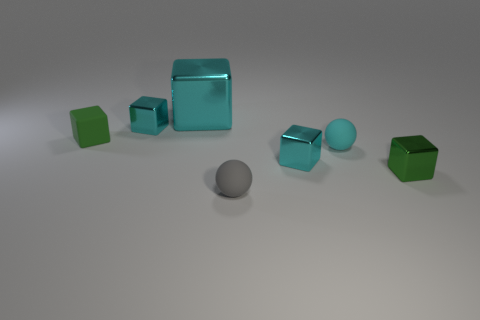Subtract all cyan blocks. How many were subtracted if there are1cyan blocks left? 2 Subtract all big metallic cubes. How many cubes are left? 4 Subtract all cyan cylinders. How many cyan blocks are left? 3 Subtract 1 cubes. How many cubes are left? 4 Subtract all gray balls. How many balls are left? 1 Add 3 tiny cyan matte things. How many objects exist? 10 Subtract all brown blocks. Subtract all purple cylinders. How many blocks are left? 5 Subtract all spheres. How many objects are left? 5 Add 6 gray balls. How many gray balls are left? 7 Add 7 green matte cubes. How many green matte cubes exist? 8 